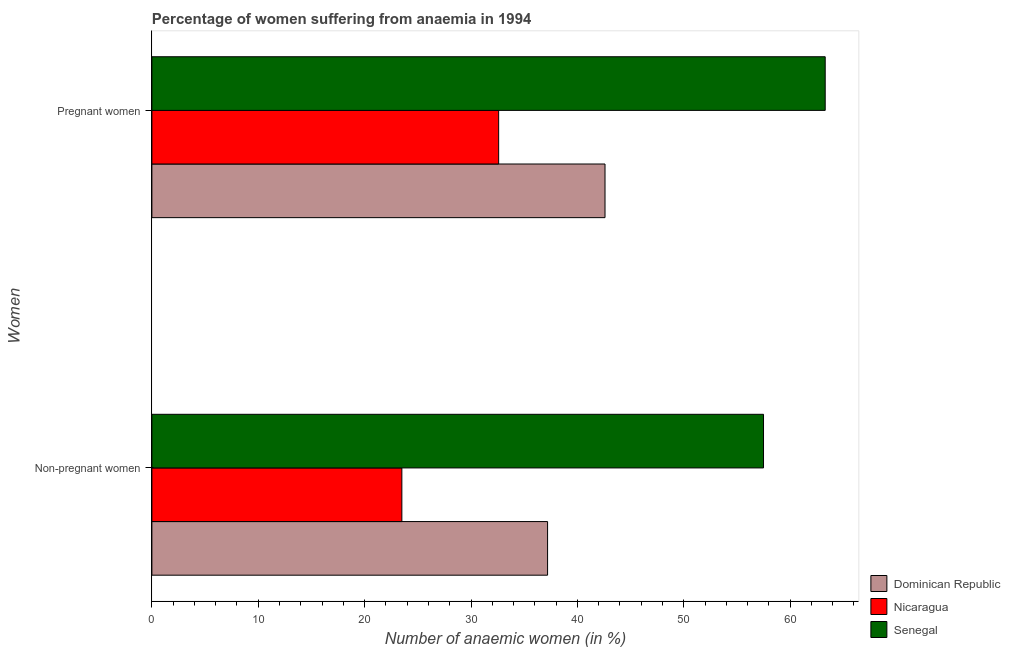How many different coloured bars are there?
Keep it short and to the point. 3. How many groups of bars are there?
Ensure brevity in your answer.  2. How many bars are there on the 1st tick from the top?
Keep it short and to the point. 3. What is the label of the 2nd group of bars from the top?
Offer a very short reply. Non-pregnant women. What is the percentage of pregnant anaemic women in Dominican Republic?
Keep it short and to the point. 42.6. Across all countries, what is the maximum percentage of pregnant anaemic women?
Provide a short and direct response. 63.3. In which country was the percentage of pregnant anaemic women maximum?
Your response must be concise. Senegal. In which country was the percentage of non-pregnant anaemic women minimum?
Provide a succinct answer. Nicaragua. What is the total percentage of non-pregnant anaemic women in the graph?
Make the answer very short. 118.2. What is the difference between the percentage of non-pregnant anaemic women in Nicaragua and that in Senegal?
Ensure brevity in your answer.  -34. What is the difference between the percentage of non-pregnant anaemic women in Nicaragua and the percentage of pregnant anaemic women in Dominican Republic?
Offer a terse response. -19.1. What is the average percentage of pregnant anaemic women per country?
Your answer should be very brief. 46.17. What is the difference between the percentage of pregnant anaemic women and percentage of non-pregnant anaemic women in Senegal?
Make the answer very short. 5.8. What is the ratio of the percentage of pregnant anaemic women in Dominican Republic to that in Senegal?
Keep it short and to the point. 0.67. Is the percentage of non-pregnant anaemic women in Nicaragua less than that in Senegal?
Provide a short and direct response. Yes. What does the 3rd bar from the top in Pregnant women represents?
Your answer should be very brief. Dominican Republic. What does the 1st bar from the bottom in Non-pregnant women represents?
Your answer should be compact. Dominican Republic. What is the difference between two consecutive major ticks on the X-axis?
Your answer should be very brief. 10. Are the values on the major ticks of X-axis written in scientific E-notation?
Provide a short and direct response. No. Where does the legend appear in the graph?
Provide a succinct answer. Bottom right. How many legend labels are there?
Keep it short and to the point. 3. How are the legend labels stacked?
Your answer should be very brief. Vertical. What is the title of the graph?
Provide a short and direct response. Percentage of women suffering from anaemia in 1994. What is the label or title of the X-axis?
Make the answer very short. Number of anaemic women (in %). What is the label or title of the Y-axis?
Offer a terse response. Women. What is the Number of anaemic women (in %) in Dominican Republic in Non-pregnant women?
Your answer should be very brief. 37.2. What is the Number of anaemic women (in %) in Nicaragua in Non-pregnant women?
Give a very brief answer. 23.5. What is the Number of anaemic women (in %) in Senegal in Non-pregnant women?
Keep it short and to the point. 57.5. What is the Number of anaemic women (in %) in Dominican Republic in Pregnant women?
Your answer should be compact. 42.6. What is the Number of anaemic women (in %) of Nicaragua in Pregnant women?
Make the answer very short. 32.6. What is the Number of anaemic women (in %) of Senegal in Pregnant women?
Provide a succinct answer. 63.3. Across all Women, what is the maximum Number of anaemic women (in %) of Dominican Republic?
Keep it short and to the point. 42.6. Across all Women, what is the maximum Number of anaemic women (in %) in Nicaragua?
Keep it short and to the point. 32.6. Across all Women, what is the maximum Number of anaemic women (in %) in Senegal?
Give a very brief answer. 63.3. Across all Women, what is the minimum Number of anaemic women (in %) of Dominican Republic?
Offer a very short reply. 37.2. Across all Women, what is the minimum Number of anaemic women (in %) of Senegal?
Your answer should be compact. 57.5. What is the total Number of anaemic women (in %) in Dominican Republic in the graph?
Keep it short and to the point. 79.8. What is the total Number of anaemic women (in %) in Nicaragua in the graph?
Ensure brevity in your answer.  56.1. What is the total Number of anaemic women (in %) of Senegal in the graph?
Your response must be concise. 120.8. What is the difference between the Number of anaemic women (in %) of Dominican Republic in Non-pregnant women and that in Pregnant women?
Make the answer very short. -5.4. What is the difference between the Number of anaemic women (in %) of Dominican Republic in Non-pregnant women and the Number of anaemic women (in %) of Nicaragua in Pregnant women?
Offer a terse response. 4.6. What is the difference between the Number of anaemic women (in %) of Dominican Republic in Non-pregnant women and the Number of anaemic women (in %) of Senegal in Pregnant women?
Provide a short and direct response. -26.1. What is the difference between the Number of anaemic women (in %) of Nicaragua in Non-pregnant women and the Number of anaemic women (in %) of Senegal in Pregnant women?
Your response must be concise. -39.8. What is the average Number of anaemic women (in %) of Dominican Republic per Women?
Provide a short and direct response. 39.9. What is the average Number of anaemic women (in %) of Nicaragua per Women?
Keep it short and to the point. 28.05. What is the average Number of anaemic women (in %) in Senegal per Women?
Ensure brevity in your answer.  60.4. What is the difference between the Number of anaemic women (in %) in Dominican Republic and Number of anaemic women (in %) in Nicaragua in Non-pregnant women?
Ensure brevity in your answer.  13.7. What is the difference between the Number of anaemic women (in %) in Dominican Republic and Number of anaemic women (in %) in Senegal in Non-pregnant women?
Ensure brevity in your answer.  -20.3. What is the difference between the Number of anaemic women (in %) of Nicaragua and Number of anaemic women (in %) of Senegal in Non-pregnant women?
Give a very brief answer. -34. What is the difference between the Number of anaemic women (in %) of Dominican Republic and Number of anaemic women (in %) of Senegal in Pregnant women?
Your answer should be compact. -20.7. What is the difference between the Number of anaemic women (in %) in Nicaragua and Number of anaemic women (in %) in Senegal in Pregnant women?
Offer a terse response. -30.7. What is the ratio of the Number of anaemic women (in %) in Dominican Republic in Non-pregnant women to that in Pregnant women?
Ensure brevity in your answer.  0.87. What is the ratio of the Number of anaemic women (in %) of Nicaragua in Non-pregnant women to that in Pregnant women?
Your answer should be very brief. 0.72. What is the ratio of the Number of anaemic women (in %) of Senegal in Non-pregnant women to that in Pregnant women?
Make the answer very short. 0.91. What is the difference between the highest and the second highest Number of anaemic women (in %) of Dominican Republic?
Provide a succinct answer. 5.4. What is the difference between the highest and the second highest Number of anaemic women (in %) of Nicaragua?
Offer a terse response. 9.1. 